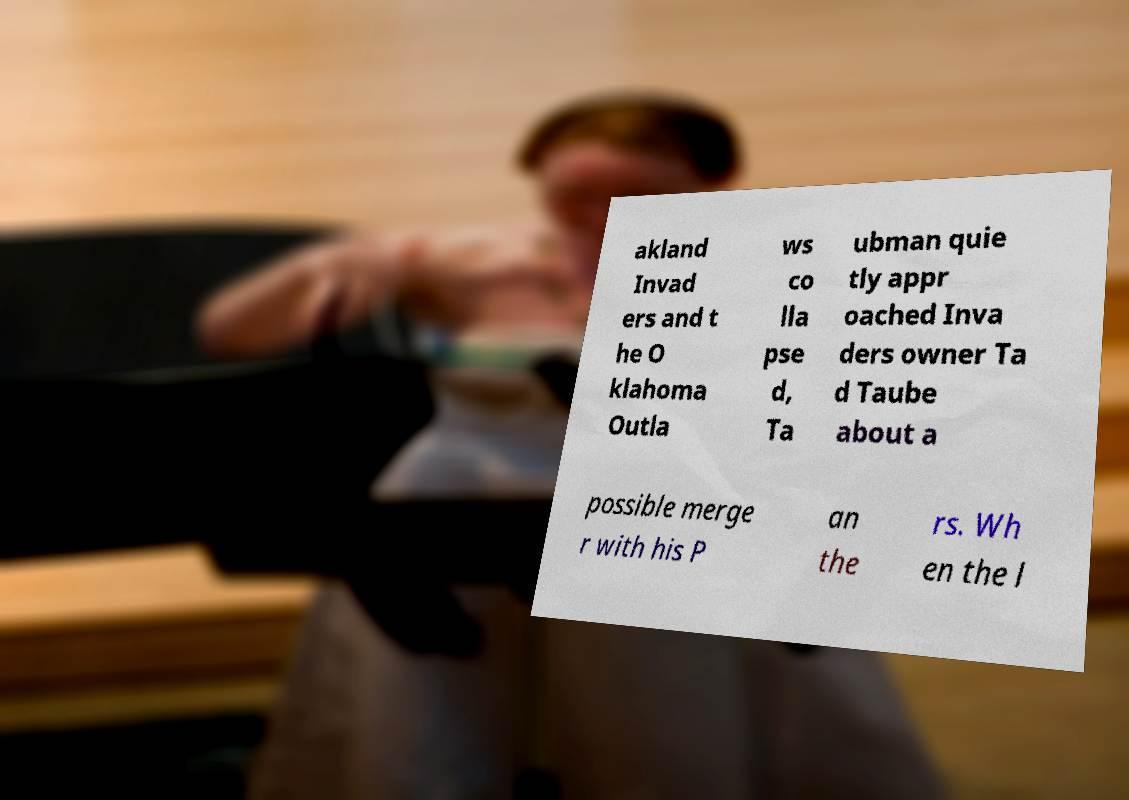Could you extract and type out the text from this image? akland Invad ers and t he O klahoma Outla ws co lla pse d, Ta ubman quie tly appr oached Inva ders owner Ta d Taube about a possible merge r with his P an the rs. Wh en the l 